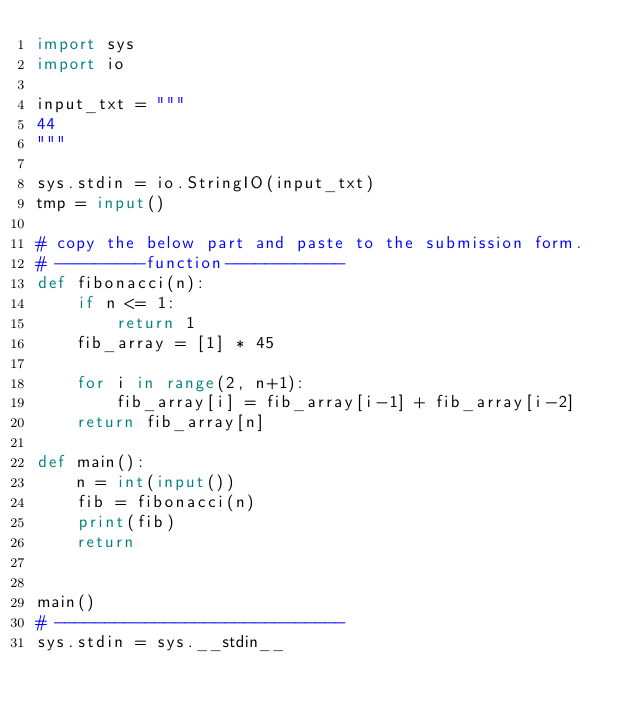Convert code to text. <code><loc_0><loc_0><loc_500><loc_500><_Python_>import sys
import io

input_txt = """
44
"""

sys.stdin = io.StringIO(input_txt)
tmp = input()

# copy the below part and paste to the submission form.
# ---------function------------
def fibonacci(n):
    if n <= 1:
        return 1
    fib_array = [1] * 45

    for i in range(2, n+1):
        fib_array[i] = fib_array[i-1] + fib_array[i-2]
    return fib_array[n]

def main():
    n = int(input())
    fib = fibonacci(n)
    print(fib)
    return


main()
# -----------------------------
sys.stdin = sys.__stdin__
</code> 